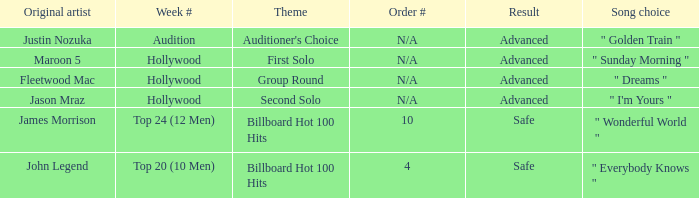What are all the topic wherein music preference is " golden train " Auditioner's Choice. 